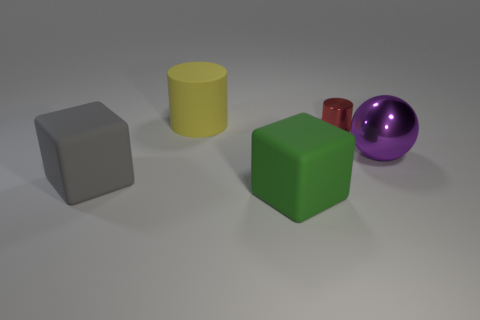Can you tell me the colors of the objects from left to right? Sure, from left to right, the objects are gray, green, yellow, red, and purple. 